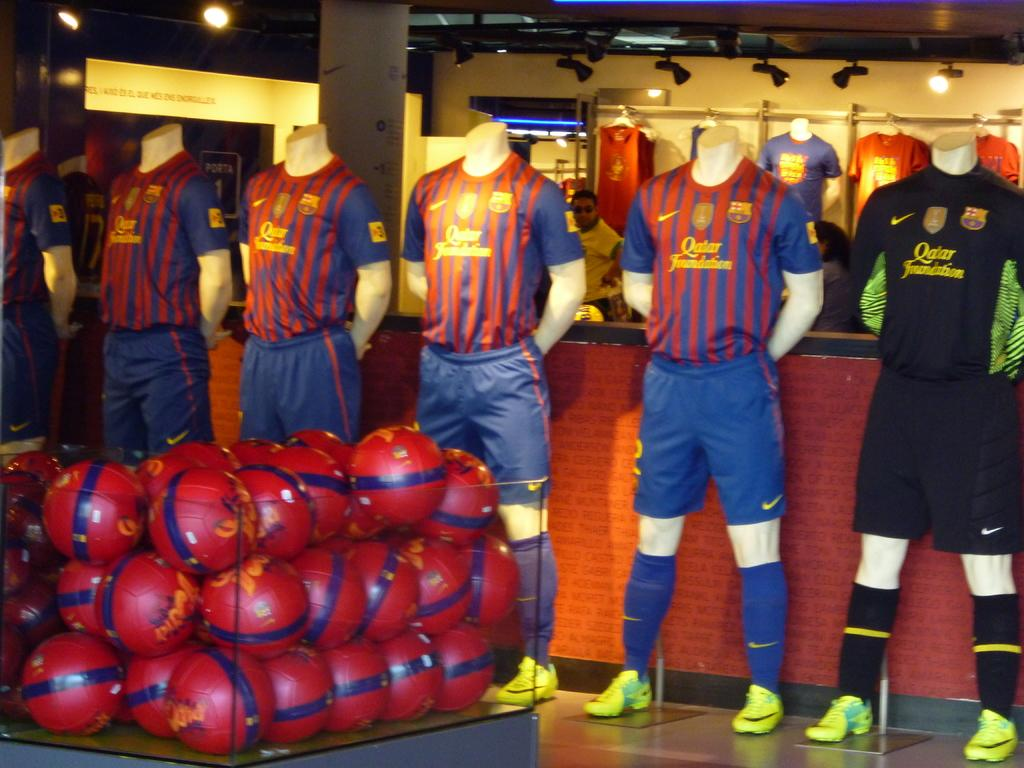Provide a one-sentence caption for the provided image. Several soccer jersey for Qatar are displayed on mannequins. 